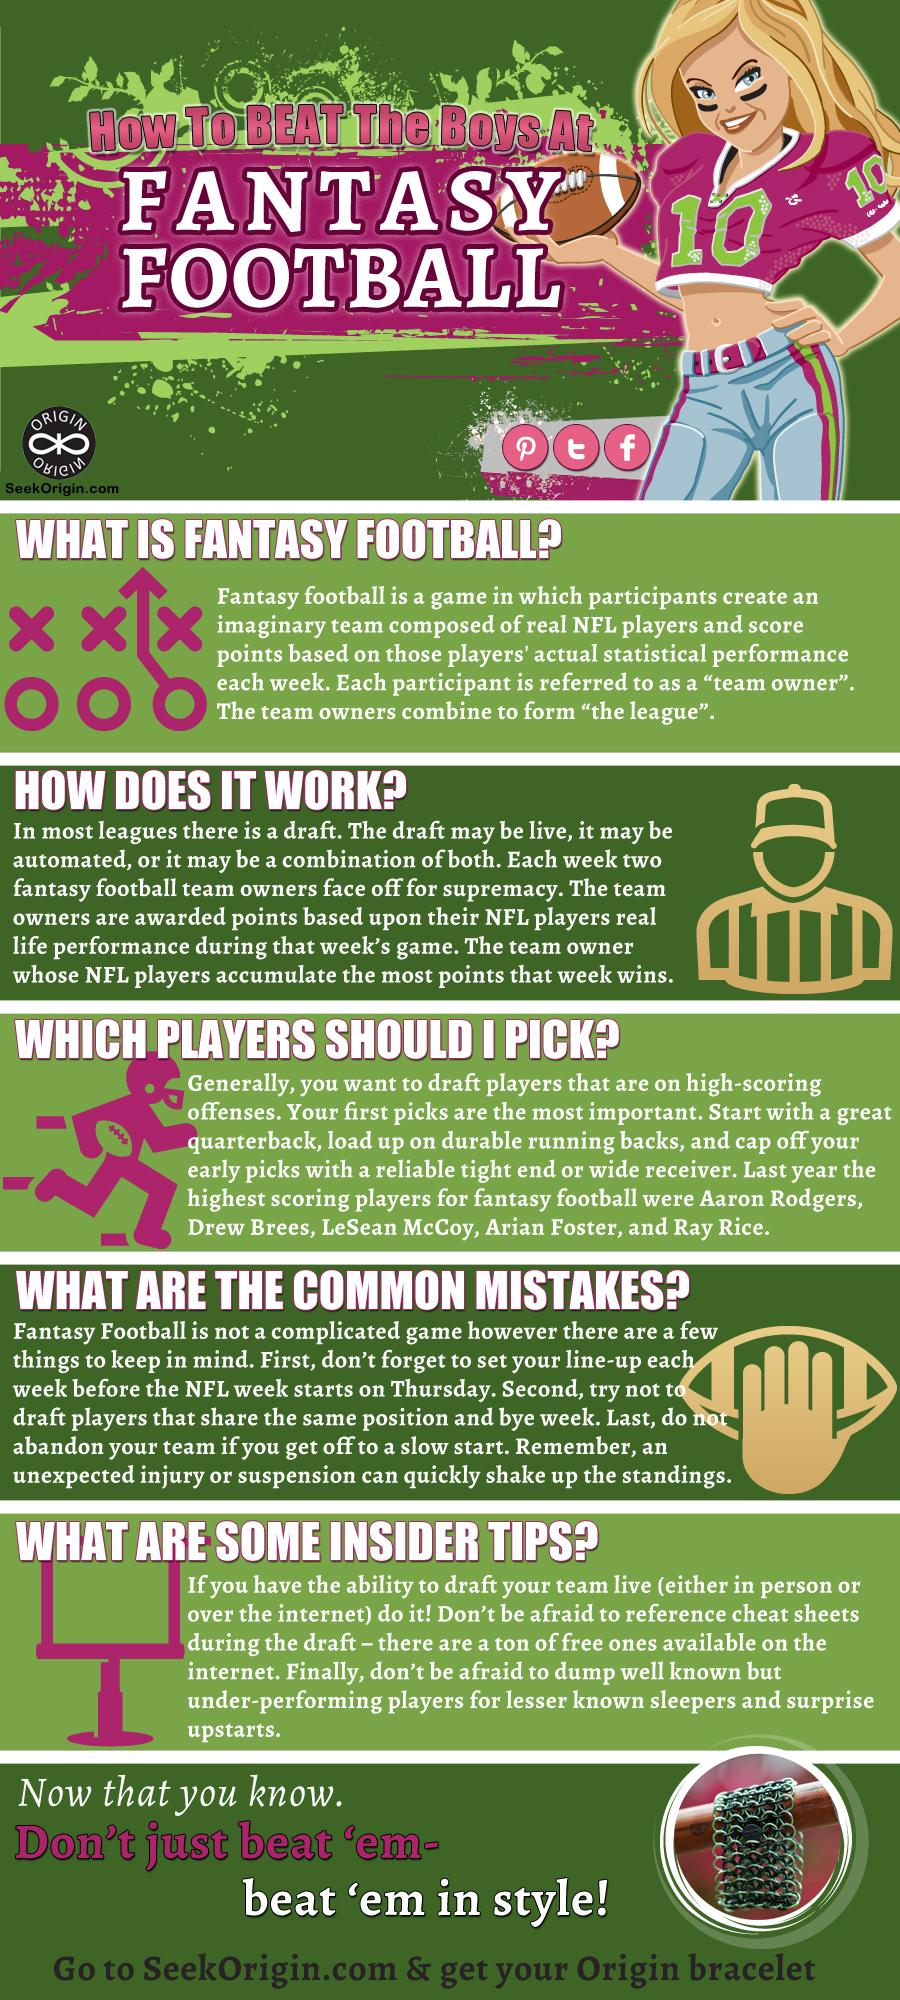Highlight a few significant elements in this photo. The second-highest scoring player is Drew Brees. The name of the NFL player who is written first is Aaron Rodgers. The group of different participants who own teams of NFL players is known as the league. 